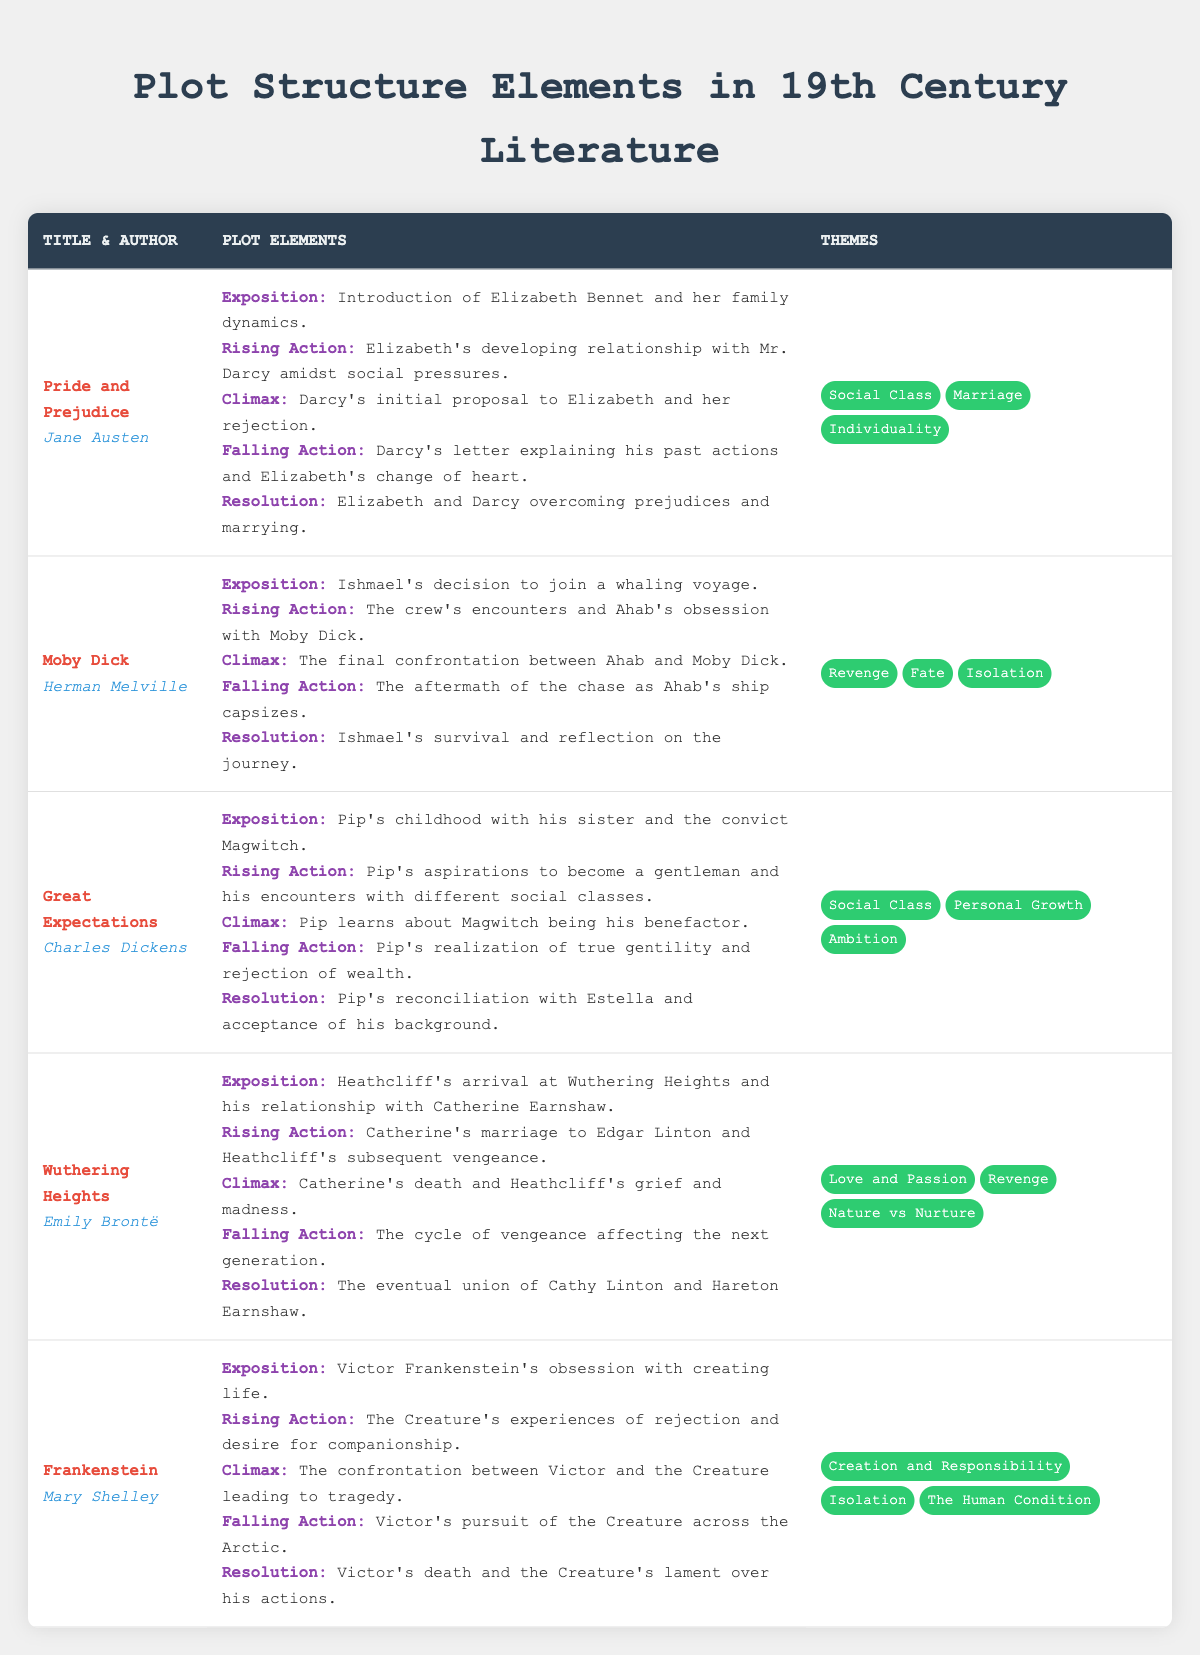What is the title of the book by Jane Austen? The author of the book is Jane Austen; therefore, the title associated with her is "Pride and Prejudice."
Answer: Pride and Prejudice Which plot element indicates the main conflict for "Moby Dick"? In "Moby Dick," the climax represents the main conflict, which is the final confrontation between Ahab and Moby Dick.
Answer: The final confrontation between Ahab and Moby Dick List one theme present in "Frankenstein." The table includes several themes for "Frankenstein", one of which is "Creation and Responsibility."
Answer: Creation and Responsibility How many different themes are present in "Wuthering Heights"? The row for "Wuthering Heights" lists three themes: "Love and Passion", "Revenge", and "Nature vs Nurture."
Answer: Three In "Great Expectations", what does Pip realize during the falling action? During the falling action of "Great Expectations", Pip realizes true gentility and rejects wealth.
Answer: He realizes true gentility and rejects wealth Which book has a climax that involves a proposal? The climax of "Pride and Prejudice" involves Darcy's proposal to Elizabeth, followed by her rejection.
Answer: Pride and Prejudice If we compare the number of themes in "Moby Dick" and "Great Expectations", which has more themes? "Moby Dick" has three themes ("Revenge", "Fate", "Isolation") while "Great Expectations" also has three themes ("Social Class", "Personal Growth", "Ambition"); therefore, they are equal.
Answer: They have the same number of themes What is the resolution for the story "Frankenstein"? The resolution for "Frankenstein" involves Victor's death and the Creature's lament over his actions, which is described at the end of the plot elements.
Answer: Victor's death and the Creature's lament over his actions Does "Wuthering Heights" have a theme that relates to love? Yes, "Wuthering Heights" includes the theme "Love and Passion", which relates to love.
Answer: Yes Which author wrote a book that includes the theme of "Social Class"? "Pride and Prejudice" and "Great Expectations" both include the theme of "Social Class," but only one of those is needed to answer the question, and both were written by different authors.
Answer: Jane Austen and Charles Dickens Are there any plot elements that involve the idea of isolation in more than one book? Yes, "Moby Dick" and "Frankenstein" both include isolation as a theme, but only in Frankenstein is it marked as a plot element regarding the Creature's experiences.
Answer: Yes 